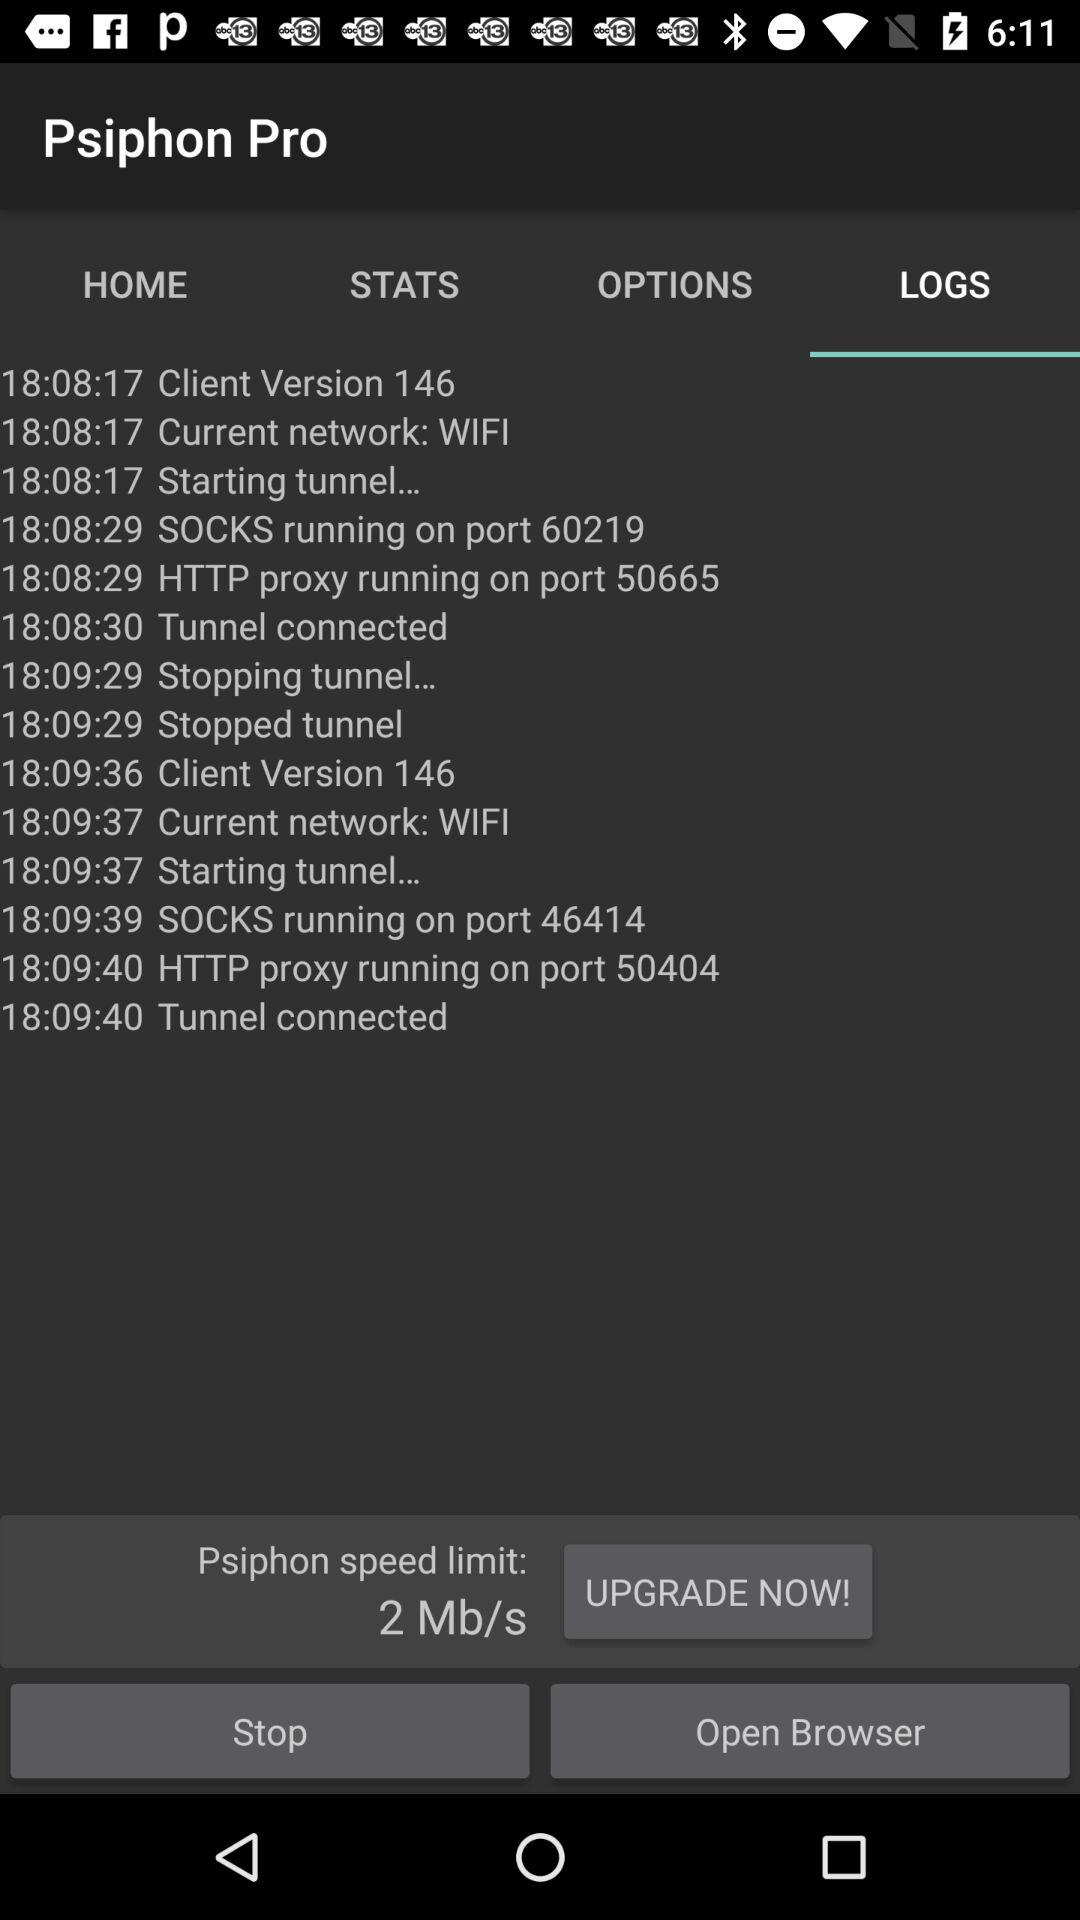What is the type of the current network? The type of the current network is WiFi. 